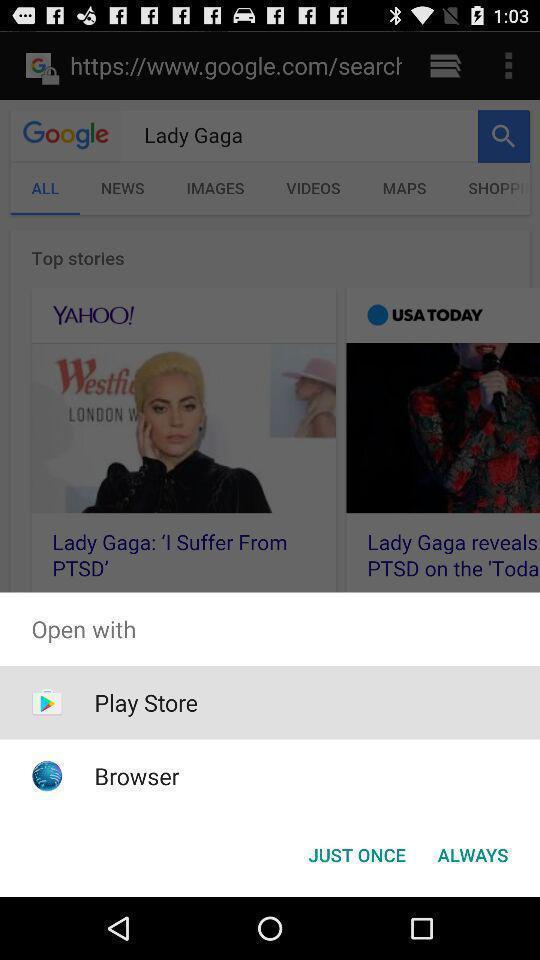Summarize the information in this screenshot. Pop-up showing available browsers to open a link. 